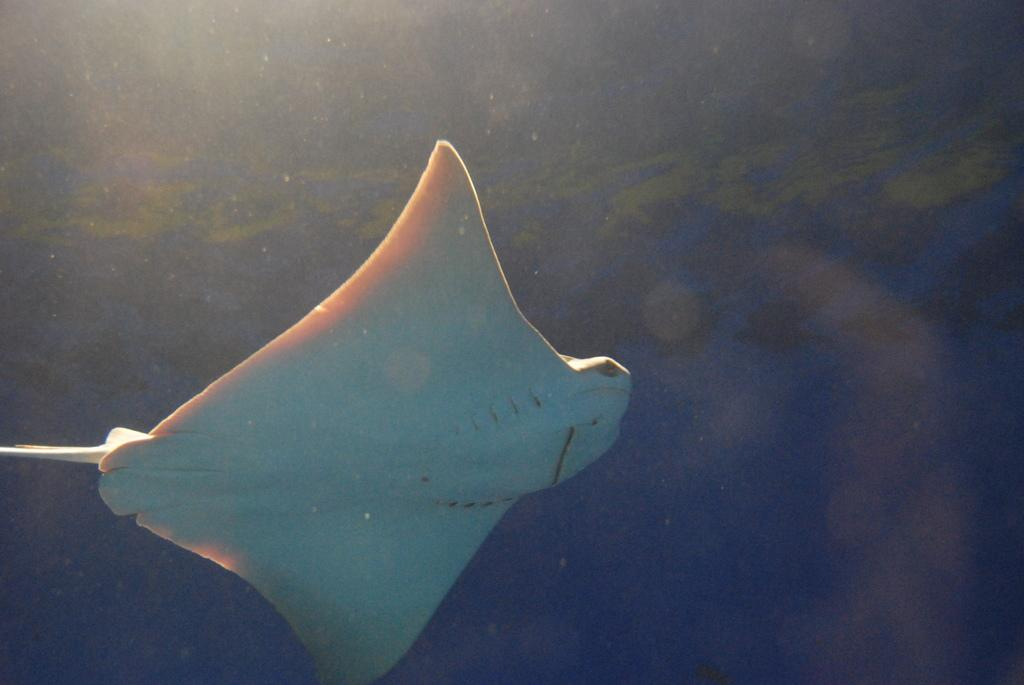What is the setting of the image? The image is underwater. Who is the owner of the underwater playground in the image? There is no underwater playground or owner mentioned in the image. 